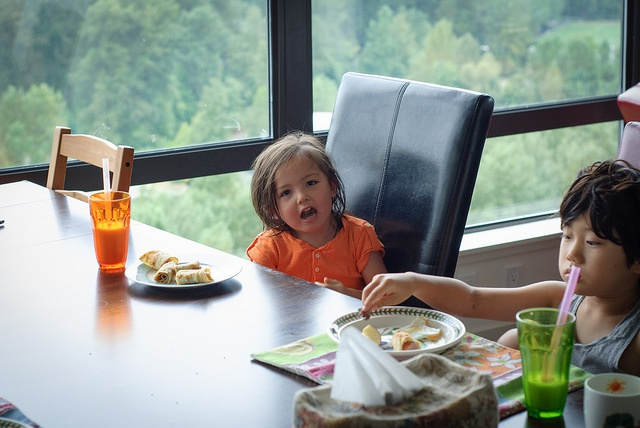Describe the objects in this image and their specific colors. I can see dining table in teal, white, darkgray, lightgray, and black tones, chair in teal, black, darkgray, and gray tones, people in teal, black, brown, gray, and maroon tones, people in teal, brown, and maroon tones, and cup in teal, darkgreen, and olive tones in this image. 